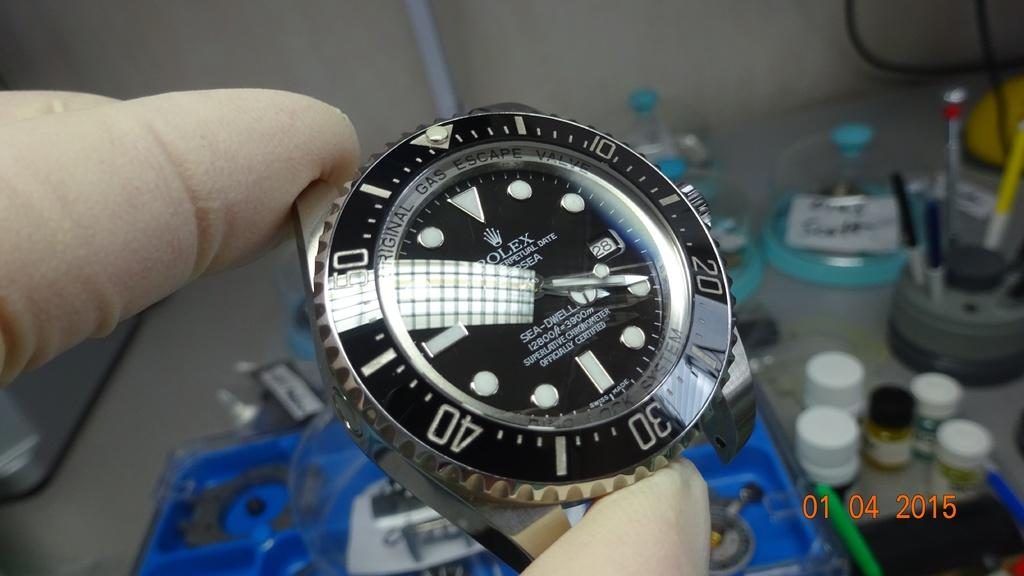<image>
Provide a brief description of the given image. Person holding a face of a watch which has the word ROLEX on the front. 